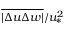Convert formula to latex. <formula><loc_0><loc_0><loc_500><loc_500>\overline { | \Delta u \Delta w | } / u _ { * } ^ { 2 }</formula> 